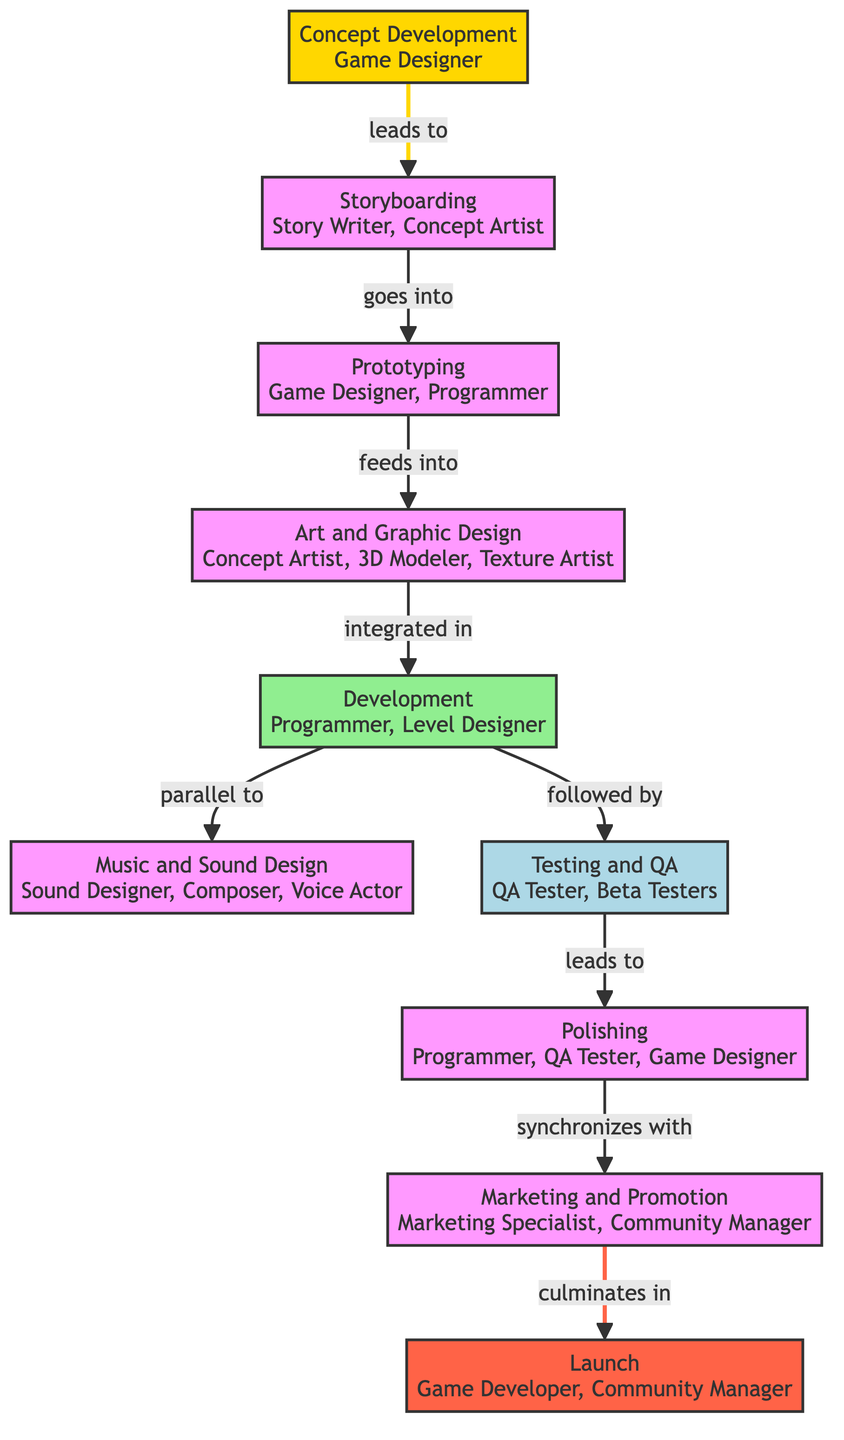What is the first stage of the game development workflow? The diagram indicates that the first stage of the game development workflow is "Concept Development", as it is the starting node from which all other stages flow.
Answer: Concept Development How many team members are involved in the "Music and Sound Design" phase? The "Music and Sound Design" phase involves three roles: Sound Designer, Composer, and Voice Actor.
Answer: Three Which stage leads to "Prototyping"? The stage that leads to "Prototyping" is "Storyboarding", as indicated by the directional connection in the diagram.
Answer: Storyboarding What stage is "Polishing" synchronized with? "Polishing" is synchronized with "Marketing and Promotion", shown by the connection that expresses their relationship in the workflow.
Answer: Marketing and Promotion In which phase do developers code game mechanics? The phase where developers code game mechanics is "Development", as stated in its description as the stage where coding and building tasks occur.
Answer: Development How many stages are there in total in the diagram? The diagram lists a total of ten stages from "Concept Development" to "Launch", making it ten stages overall.
Answer: Ten What role is primarily involved in "Testing and QA"? The primary role involved in "Testing and QA" is "QA Tester" as mentioned in the stage's description.
Answer: QA Tester Which two stages occur in parallel during the development process? The stages that occur in parallel during the development process are "Development" and "Music and Sound Design". The diagram explicitly states this relationship.
Answer: Development and Music Sound Design What is the last stage before the game is released? The last stage before the game is released is "Marketing and Promotion", which culminates in the "Launch" stage.
Answer: Marketing and Promotion 